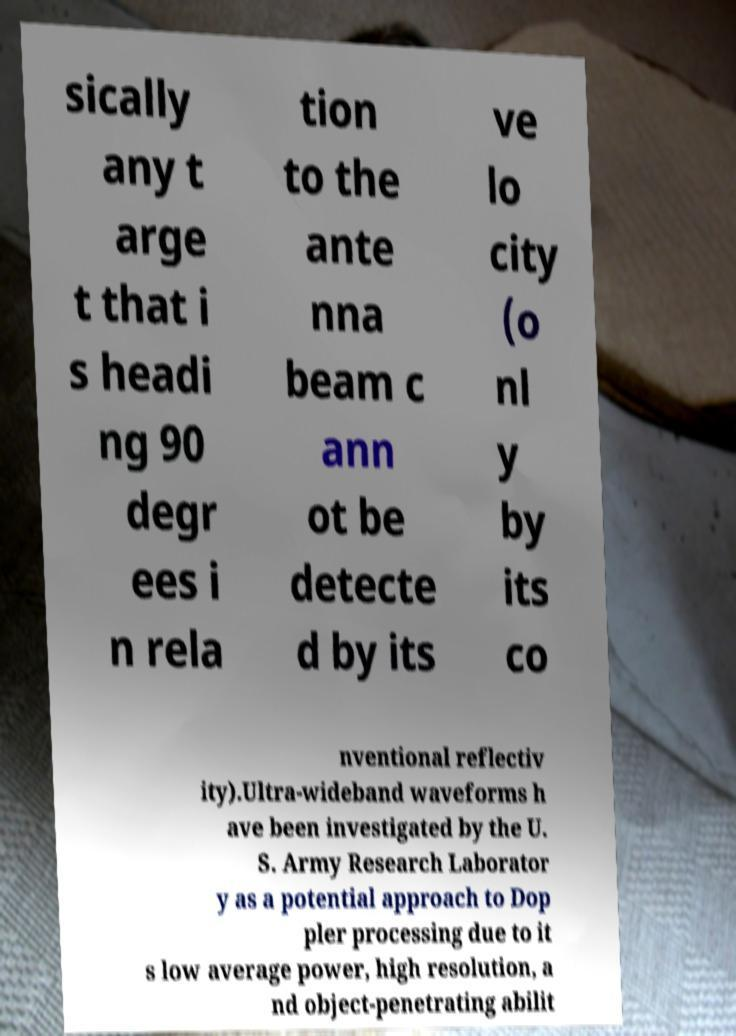Please identify and transcribe the text found in this image. sically any t arge t that i s headi ng 90 degr ees i n rela tion to the ante nna beam c ann ot be detecte d by its ve lo city (o nl y by its co nventional reflectiv ity).Ultra-wideband waveforms h ave been investigated by the U. S. Army Research Laborator y as a potential approach to Dop pler processing due to it s low average power, high resolution, a nd object-penetrating abilit 